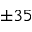<formula> <loc_0><loc_0><loc_500><loc_500>\pm 3 5</formula> 